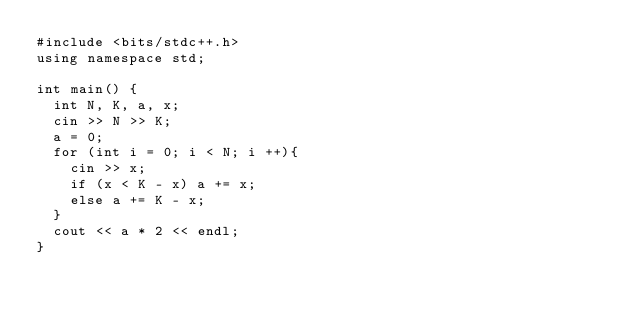Convert code to text. <code><loc_0><loc_0><loc_500><loc_500><_C++_>#include <bits/stdc++.h>
using namespace std;

int main() {
  int N, K, a, x;
  cin >> N >> K;
  a = 0;
  for (int i = 0; i < N; i ++){
    cin >> x;
    if (x < K - x) a += x;
    else a += K - x;
  }
  cout << a * 2 << endl;
}
</code> 